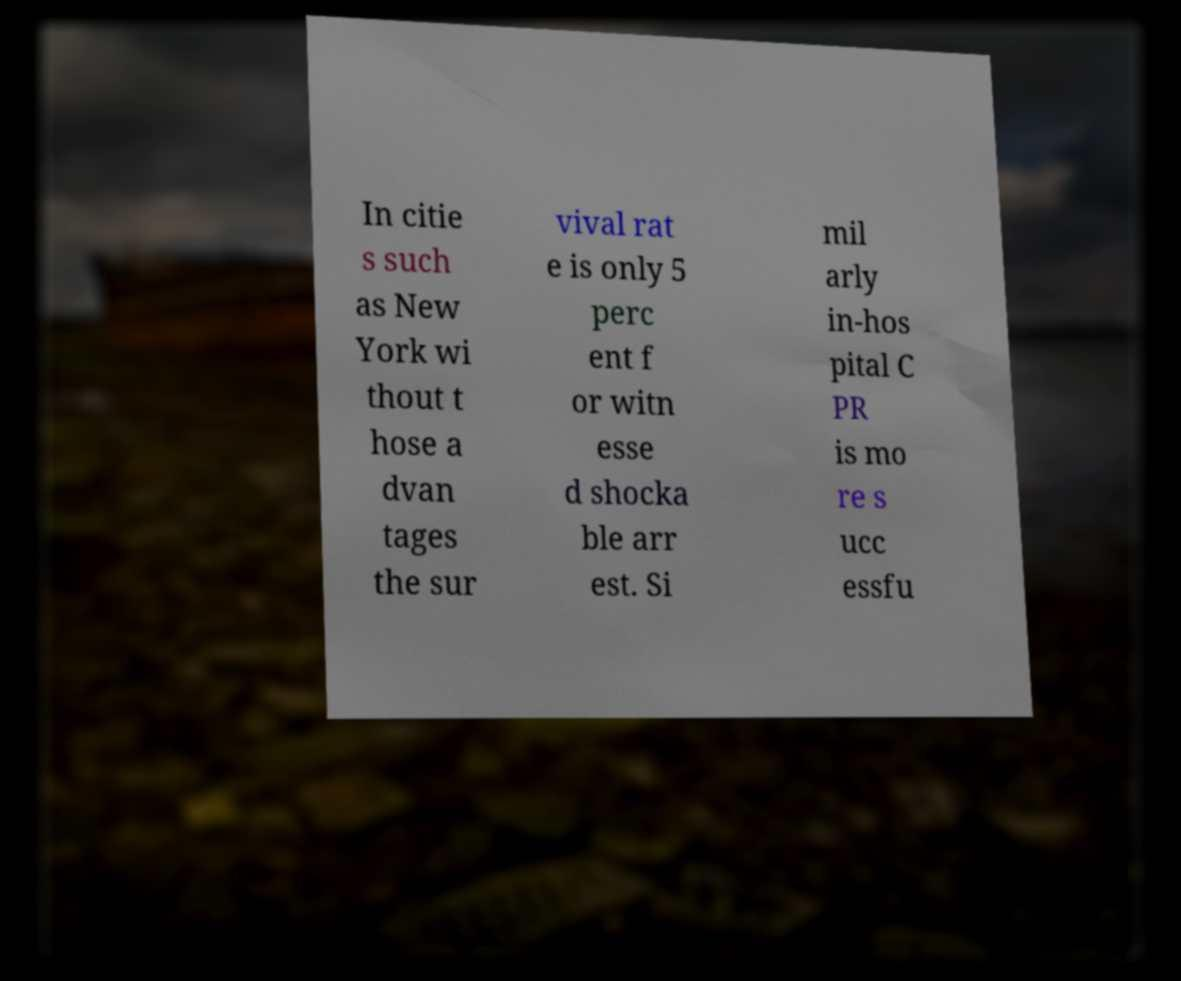Please identify and transcribe the text found in this image. In citie s such as New York wi thout t hose a dvan tages the sur vival rat e is only 5 perc ent f or witn esse d shocka ble arr est. Si mil arly in-hos pital C PR is mo re s ucc essfu 